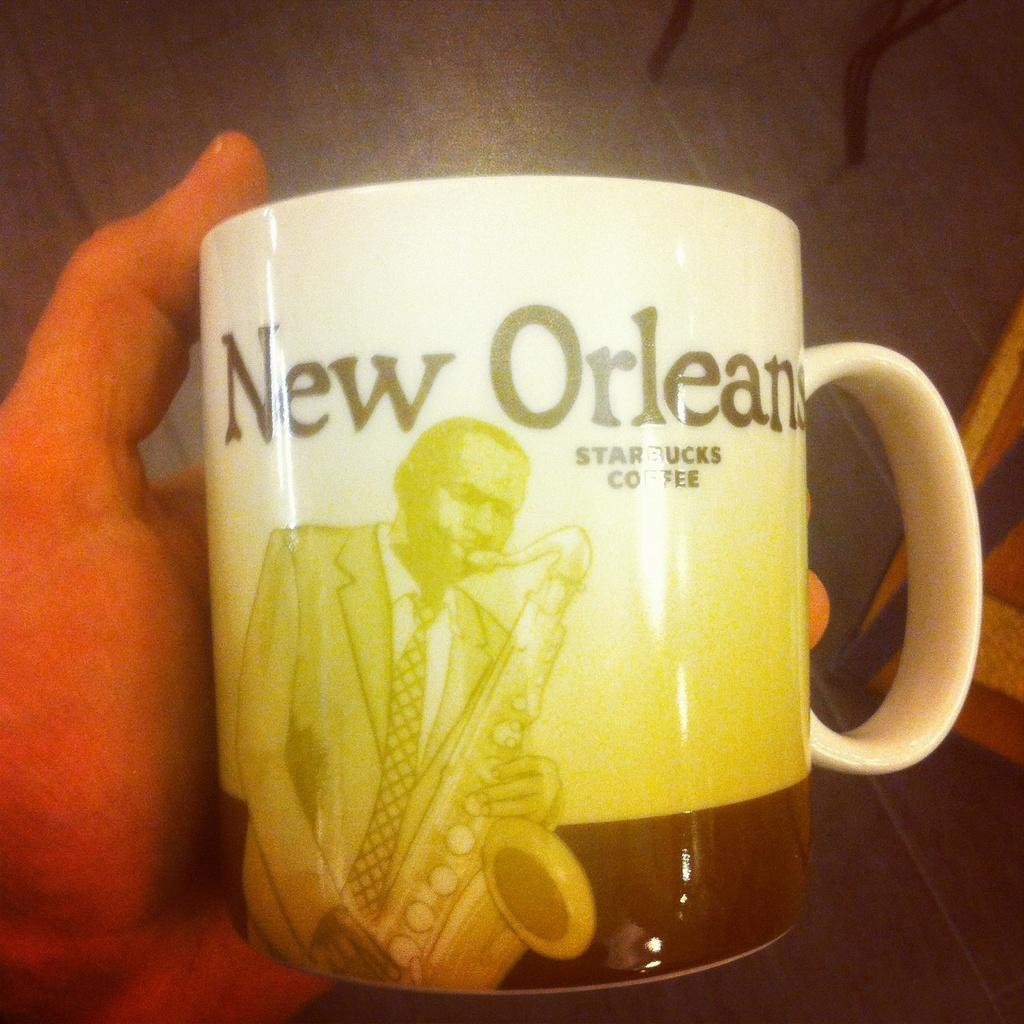<image>
Share a concise interpretation of the image provided. A coffee mug from the Starbucks at New Orleans. 